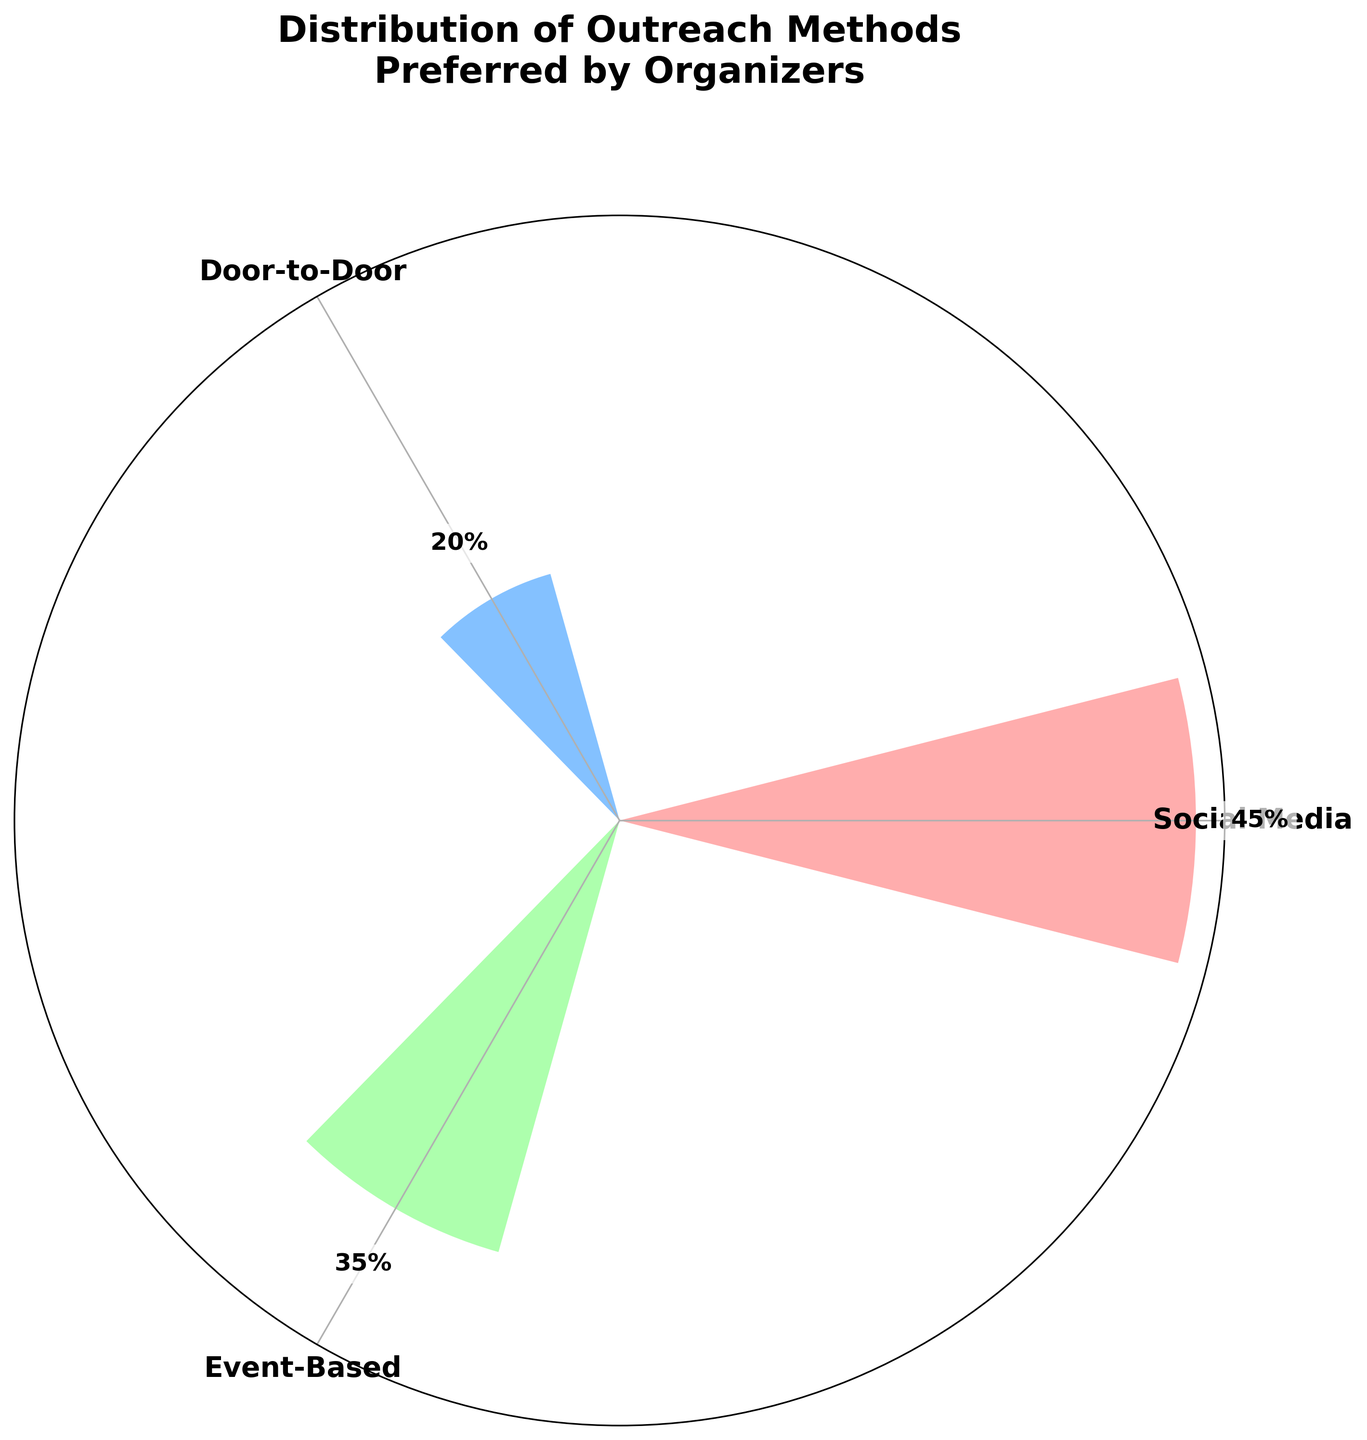What's the title of the figure? The title is located at the top of the figure, prominently displayed. It reads "Distribution of Outreach Methods Preferred by Organizers".
Answer: Distribution of Outreach Methods Preferred by Organizers How many outreach methods are shown in the figure? The figure displays three distinct outreach methods, each represented by a different section on the rose chart.
Answer: Three Which outreach method has the highest percentage? The method with the highest percentage can be determined by identifying the largest bar in the rose chart. The longest bar corresponds to "Social Media", which has a percentage directly labeled as 45%.
Answer: Social Media What's the percentage for Event-Based outreach? The percentage is directly labeled on the corresponding segment of the rose chart for "Event-Based". It reads 35%.
Answer: 35% Compare the percentages of Social Media and Door-to-Door outreach. Which one is higher and by how much? Social Media has 45% and Door-to-Door has 20%. By subtracting the percentage of Door-to-Door from Social Media (45% - 20%), we find that Social Media is higher by 25 percentage points.
Answer: Social Media is higher by 25% What is the total percentage of organizers preferring either Door-to-Door or Event-Based methods? To find the total percentage, add the percentages of Door-to-Door (20%) and Event-Based (35%). The sum is 20% + 35% = 55%.
Answer: 55% By what factor is the Social Media preference greater than the Door-to-Door preference? Divide the percentage of Social Media (45%) by the percentage of Door-to-Door (20%) to find the factor. 45 / 20 = 2.25.
Answer: 2.25 Which method has the smallest preference among organizers? The shortest segment on the rose chart corresponds to the method with the smallest preference. Door-to-Door, which has a percentage of 20%, is the smallest.
Answer: Door-to-Door If the preference for Event-Based outreach increases by 10%, how would its new percentage compare to Social Media? If Event-Based increases by 10%, it would have 35% + 10% = 45%. This equals the current percentage of Social Media, making them equal.
Answer: Equal to Social Media What's the average percentage of preference across all three methods? Add the percentages for all three methods (45% for Social Media, 20% for Door-to-Door, and 35% for Event-Based) and then divide by 3. (45% + 20% + 35%) / 3 = 100% / 3 = 33.33%.
Answer: 33.33% 